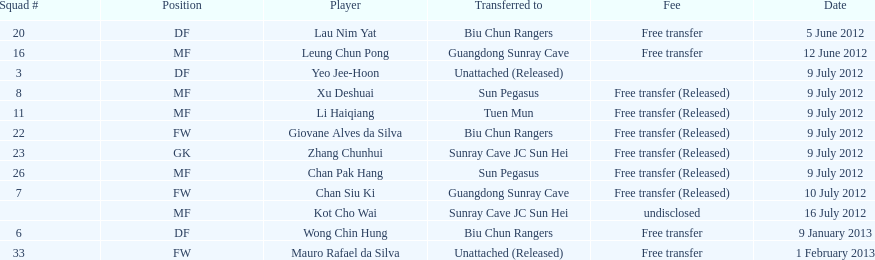What position is adjacent to squad #3? DF. 